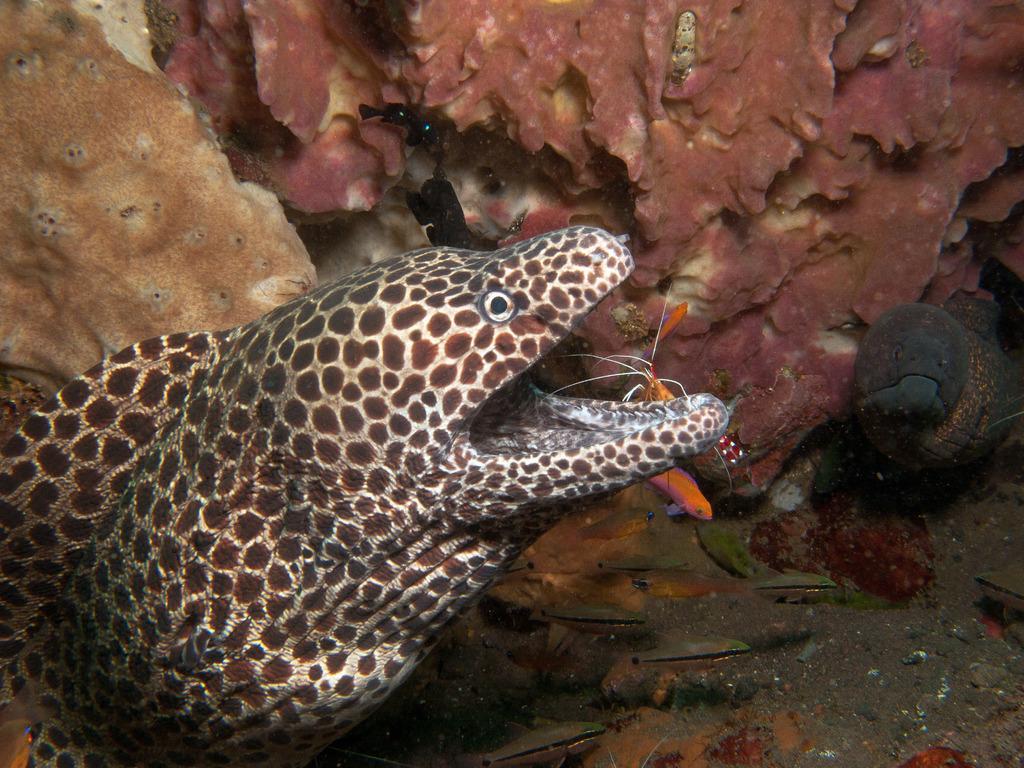Please provide a concise description of this image. In this image we can see there is an underwater environment and fishes and few animals in it. 